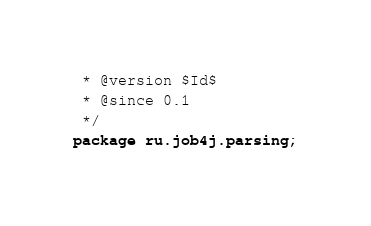<code> <loc_0><loc_0><loc_500><loc_500><_Java_> * @version $Id$
 * @since 0.1
 */
package ru.job4j.parsing;</code> 